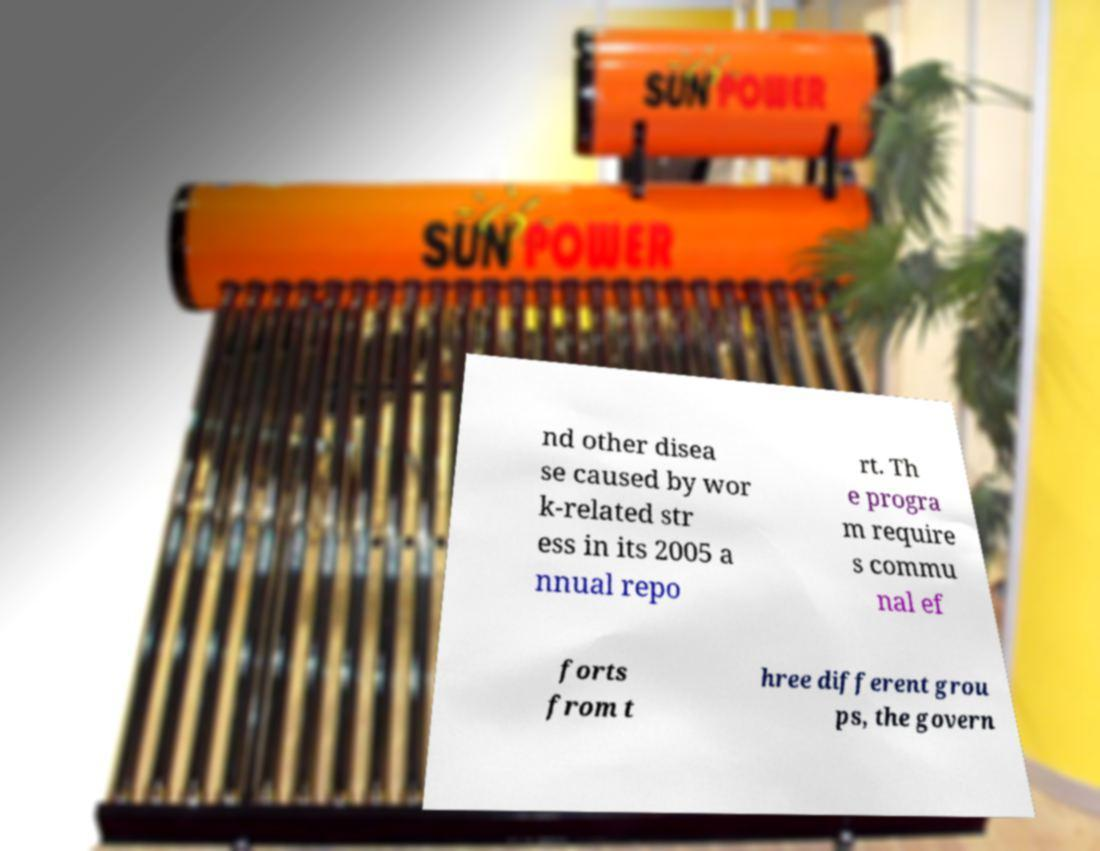Could you assist in decoding the text presented in this image and type it out clearly? nd other disea se caused by wor k-related str ess in its 2005 a nnual repo rt. Th e progra m require s commu nal ef forts from t hree different grou ps, the govern 